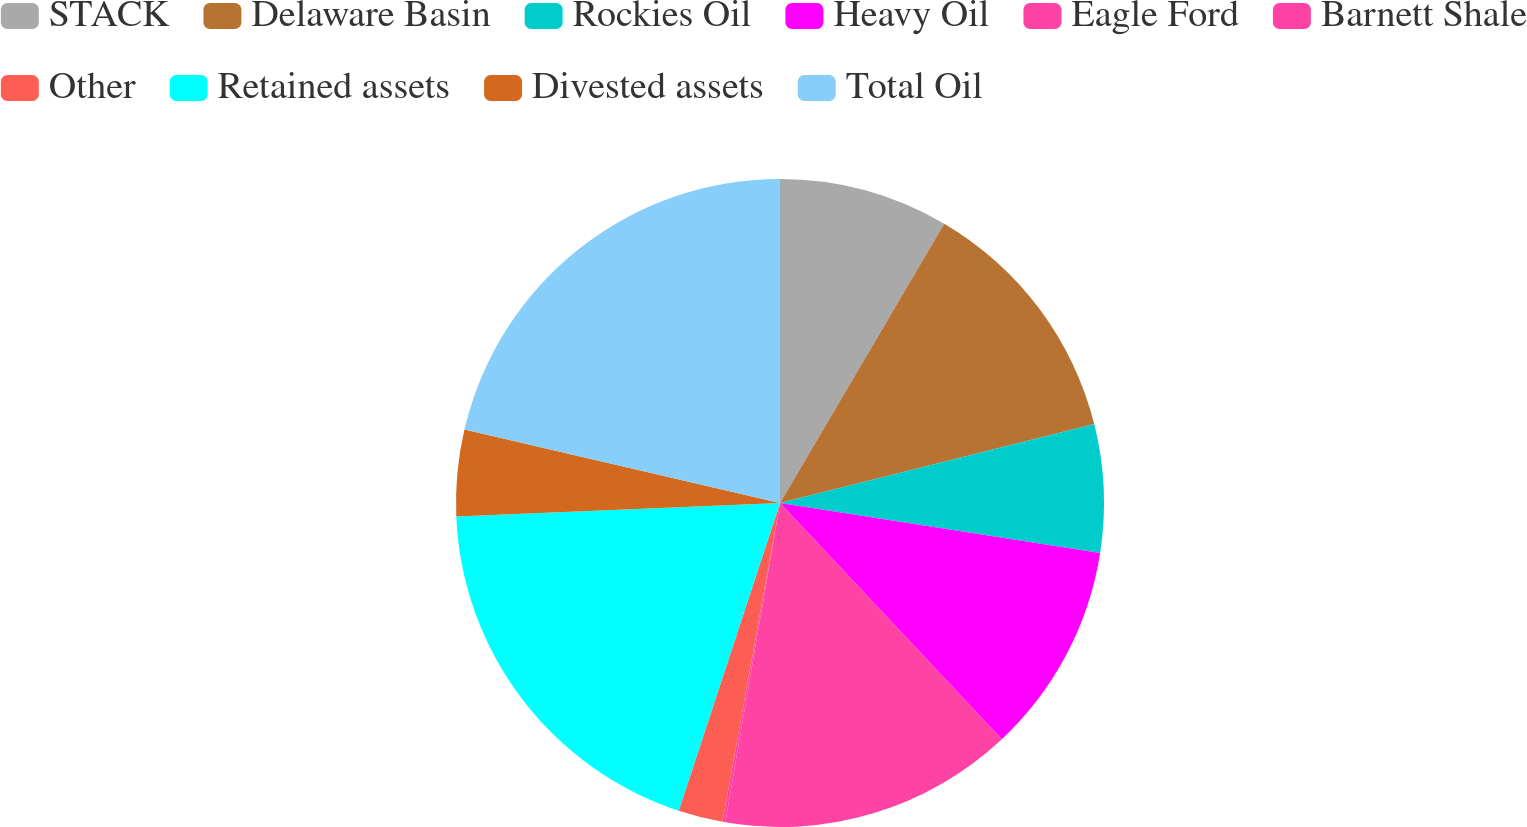Convert chart to OTSL. <chart><loc_0><loc_0><loc_500><loc_500><pie_chart><fcel>STACK<fcel>Delaware Basin<fcel>Rockies Oil<fcel>Heavy Oil<fcel>Eagle Ford<fcel>Barnett Shale<fcel>Other<fcel>Retained assets<fcel>Divested assets<fcel>Total Oil<nl><fcel>8.46%<fcel>12.62%<fcel>6.38%<fcel>10.54%<fcel>14.7%<fcel>0.14%<fcel>2.22%<fcel>19.28%<fcel>4.3%<fcel>21.36%<nl></chart> 